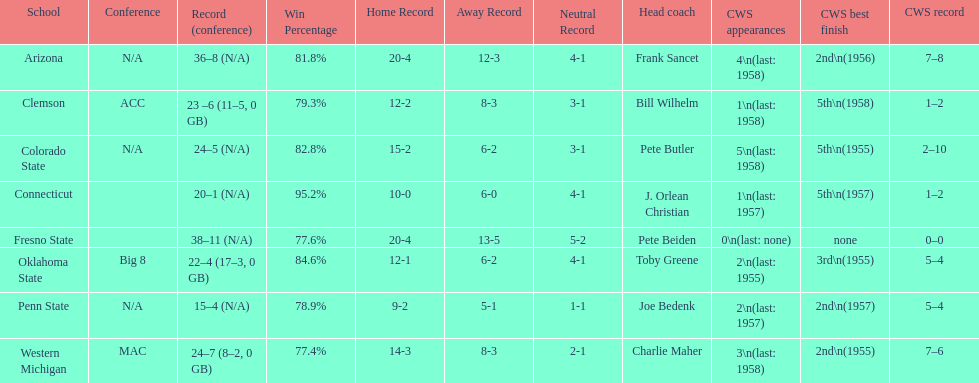Can you parse all the data within this table? {'header': ['School', 'Conference', 'Record (conference)', 'Win Percentage', 'Home Record', 'Away Record', 'Neutral Record', 'Head coach', 'CWS appearances', 'CWS best finish', 'CWS record'], 'rows': [['Arizona', 'N/A', '36–8 (N/A)', '81.8%', '20-4', '12-3', '4-1', 'Frank Sancet', '4\\n(last: 1958)', '2nd\\n(1956)', '7–8'], ['Clemson', 'ACC', '23 –6 (11–5, 0 GB)', '79.3%', '12-2', '8-3', '3-1', 'Bill Wilhelm', '1\\n(last: 1958)', '5th\\n(1958)', '1–2'], ['Colorado State', 'N/A', '24–5 (N/A)', '82.8%', '15-2', '6-2', '3-1', 'Pete Butler', '5\\n(last: 1958)', '5th\\n(1955)', '2–10'], ['Connecticut', '', '20–1 (N/A)', '95.2%', '10-0', '6-0', '4-1', 'J. Orlean Christian', '1\\n(last: 1957)', '5th\\n(1957)', '1–2'], ['Fresno State', '', '38–11 (N/A)', '77.6%', '20-4', '13-5', '5-2', 'Pete Beiden', '0\\n(last: none)', 'none', '0–0'], ['Oklahoma State', 'Big 8', '22–4 (17–3, 0 GB)', '84.6%', '12-1', '6-2', '4-1', 'Toby Greene', '2\\n(last: 1955)', '3rd\\n(1955)', '5–4'], ['Penn State', 'N/A', '15–4 (N/A)', '78.9%', '9-2', '5-1', '1-1', 'Joe Bedenk', '2\\n(last: 1957)', '2nd\\n(1957)', '5–4'], ['Western Michigan', 'MAC', '24–7 (8–2, 0 GB)', '77.4%', '14-3', '8-3', '2-1', 'Charlie Maher', '3\\n(last: 1958)', '2nd\\n(1955)', '7–6']]} Oklahoma state and penn state both have how many cws appearances? 2. 